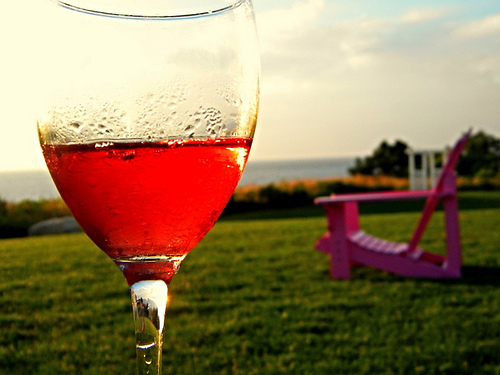<image>
Can you confirm if the glass is behind the seat? No. The glass is not behind the seat. From this viewpoint, the glass appears to be positioned elsewhere in the scene. 